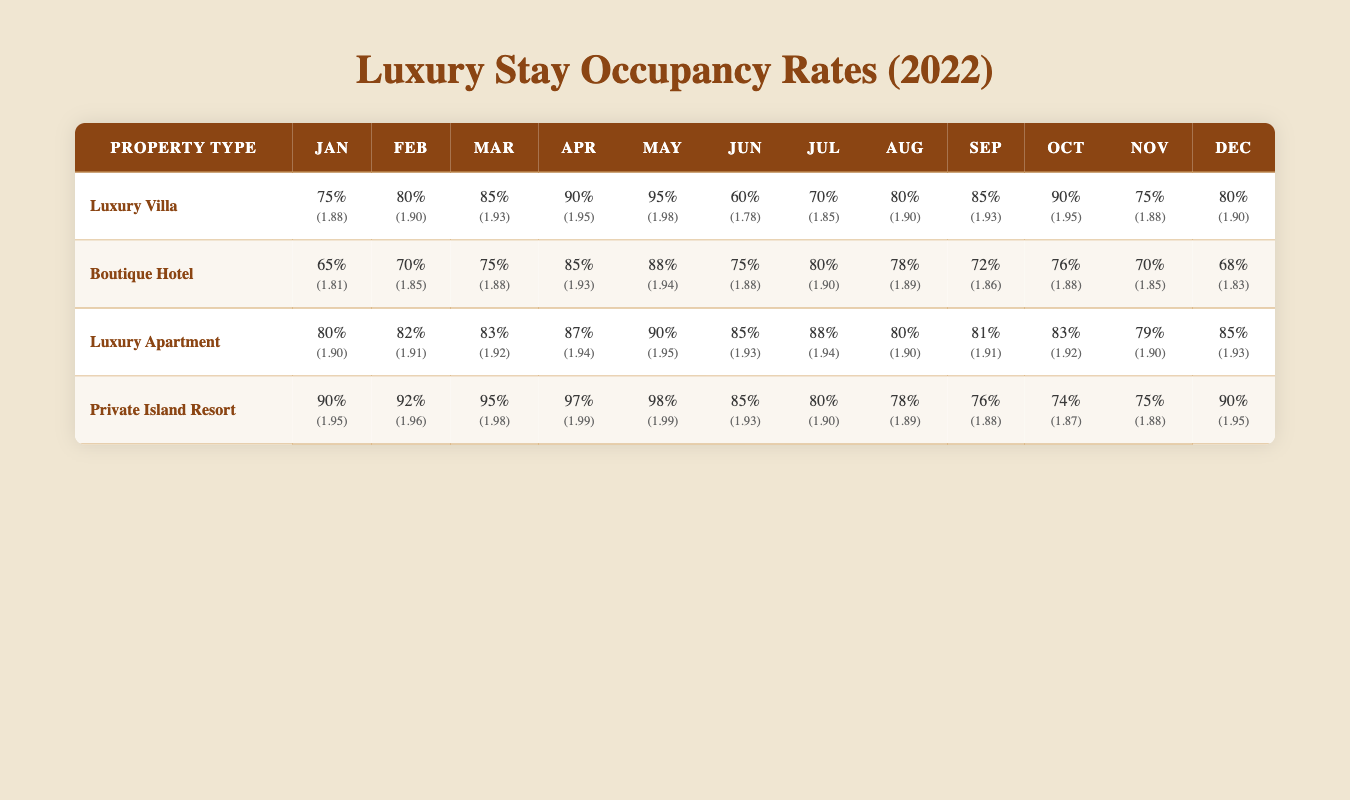What is the occupancy rate for Luxury Villas in December? From the table, the occupancy rate for Luxury Villas in December is 80%.
Answer: 80% What is the average occupancy rate for Boutique Hotels from January to December? To find the average, sum all the monthly rates: (65 + 70 + 75 + 85 + 88 + 75 + 80 + 78 + 72 + 76 + 70 + 68) =  891. There are 12 months, so divide by 12: 891 / 12 = 74.25.
Answer: 74.25 Did Private Island Resorts have a higher occupancy rate in March than Luxury Apartments? In March, the occupancy rate for Private Island Resorts is 95% while for Luxury Apartments it is 83%. Therefore, Private Island Resorts had a higher rate.
Answer: Yes Which property type had the highest occupancy rate in August? The occupancy rate for each type in August is: Luxury Villa 80%, Boutique Hotel 78%, Luxury Apartment 80%, Private Island Resort 78%. The highest rates are 80% for both Luxury Villa and Luxury Apartment.
Answer: Luxury Villa and Luxury Apartment What is the total occupancy rate for Luxury Villas from January to April? To find the total rate, sum the occupancy rates for the specified months: (75 + 80 + 85 + 90) = 330. The total occupancy rate for Luxury Villas from January to April is 330.
Answer: 330 What was the best month for occupancy for Luxury Apartments? By checking the table, in May, the occupancy rate for Luxury Apartments is 90%, which is the highest compared to other months.
Answer: May How many months did Boutique Hotels have an occupancy rate below 75%? By reviewing the table, the months with rates below 75% are January (65%) and December (68%), a total of 2 months.
Answer: 2 Which property type had the highest occupancy rate in May, and what was that rate? In May, the occupancy rates are as follows: Luxury Villa 95%, Boutique Hotel 88%, Luxury Apartment 90%, and Private Island Resort 98%. The highest is the Private Island Resort with 98%.
Answer: Private Island Resort, 98% What is the difference between the average occupancy rates of Private Island Resort and Luxury Apartment for the entire year? The average for Private Island Resort is (90 + 92 + 95 + 97 + 98 + 85 + 80 + 78 + 76 + 74 + 75 + 90) = 85.75. The average for Luxury Apartment is (80 + 82 + 83 + 87 + 90 + 85 + 88 + 80 + 81 + 83 + 79 + 85) = 84.25. The difference is 85.75 - 84.25 = 1.5.
Answer: 1.5 